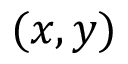Convert formula to latex. <formula><loc_0><loc_0><loc_500><loc_500>( x , y )</formula> 